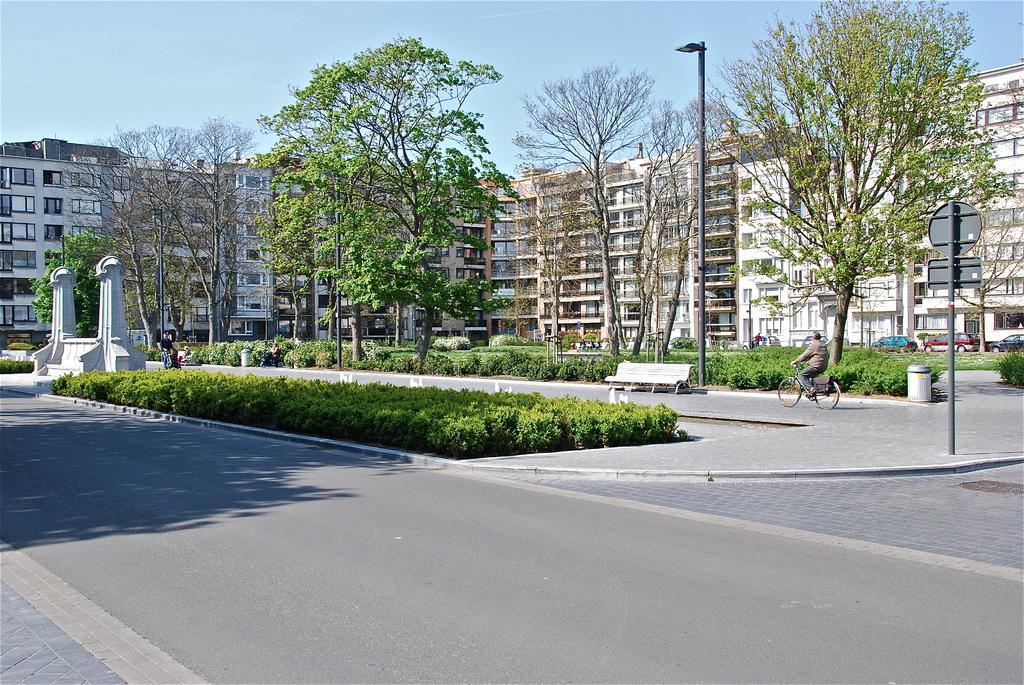In one or two sentences, can you explain what this image depicts? In this image I can see planets, light poles, pillars, a person is riding a bicycle on the road, trees and a group of people are sitting on the benches. In the background I can see buildings, windows, vehicles on the road and the sky. This image is taken may be on the road. 